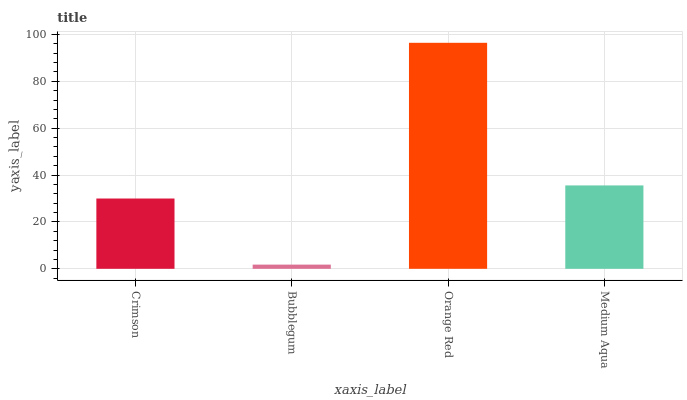Is Bubblegum the minimum?
Answer yes or no. Yes. Is Orange Red the maximum?
Answer yes or no. Yes. Is Orange Red the minimum?
Answer yes or no. No. Is Bubblegum the maximum?
Answer yes or no. No. Is Orange Red greater than Bubblegum?
Answer yes or no. Yes. Is Bubblegum less than Orange Red?
Answer yes or no. Yes. Is Bubblegum greater than Orange Red?
Answer yes or no. No. Is Orange Red less than Bubblegum?
Answer yes or no. No. Is Medium Aqua the high median?
Answer yes or no. Yes. Is Crimson the low median?
Answer yes or no. Yes. Is Bubblegum the high median?
Answer yes or no. No. Is Medium Aqua the low median?
Answer yes or no. No. 